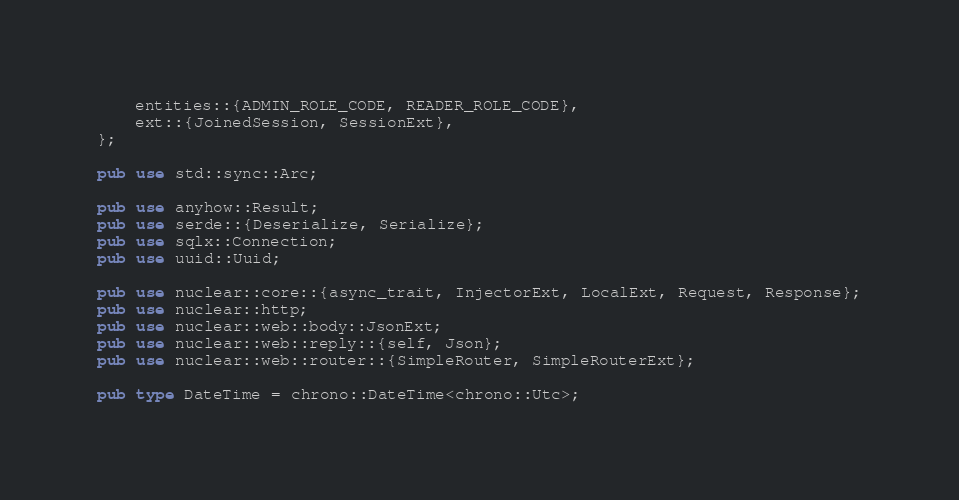Convert code to text. <code><loc_0><loc_0><loc_500><loc_500><_Rust_>    entities::{ADMIN_ROLE_CODE, READER_ROLE_CODE},
    ext::{JoinedSession, SessionExt},
};

pub use std::sync::Arc;

pub use anyhow::Result;
pub use serde::{Deserialize, Serialize};
pub use sqlx::Connection;
pub use uuid::Uuid;

pub use nuclear::core::{async_trait, InjectorExt, LocalExt, Request, Response};
pub use nuclear::http;
pub use nuclear::web::body::JsonExt;
pub use nuclear::web::reply::{self, Json};
pub use nuclear::web::router::{SimpleRouter, SimpleRouterExt};

pub type DateTime = chrono::DateTime<chrono::Utc>;
</code> 